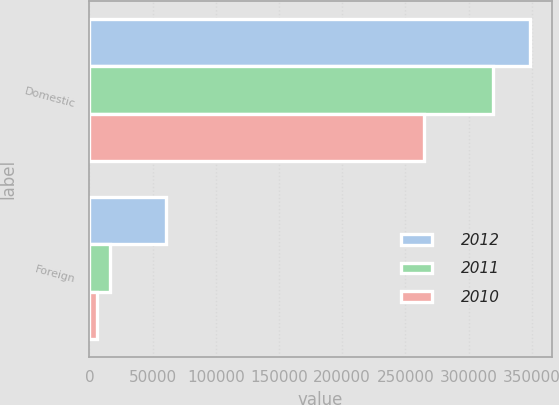Convert chart. <chart><loc_0><loc_0><loc_500><loc_500><stacked_bar_chart><ecel><fcel>Domestic<fcel>Foreign<nl><fcel>2012<fcel>348150<fcel>61017<nl><fcel>2011<fcel>319305<fcel>16466<nl><fcel>2010<fcel>264438<fcel>5687<nl></chart> 